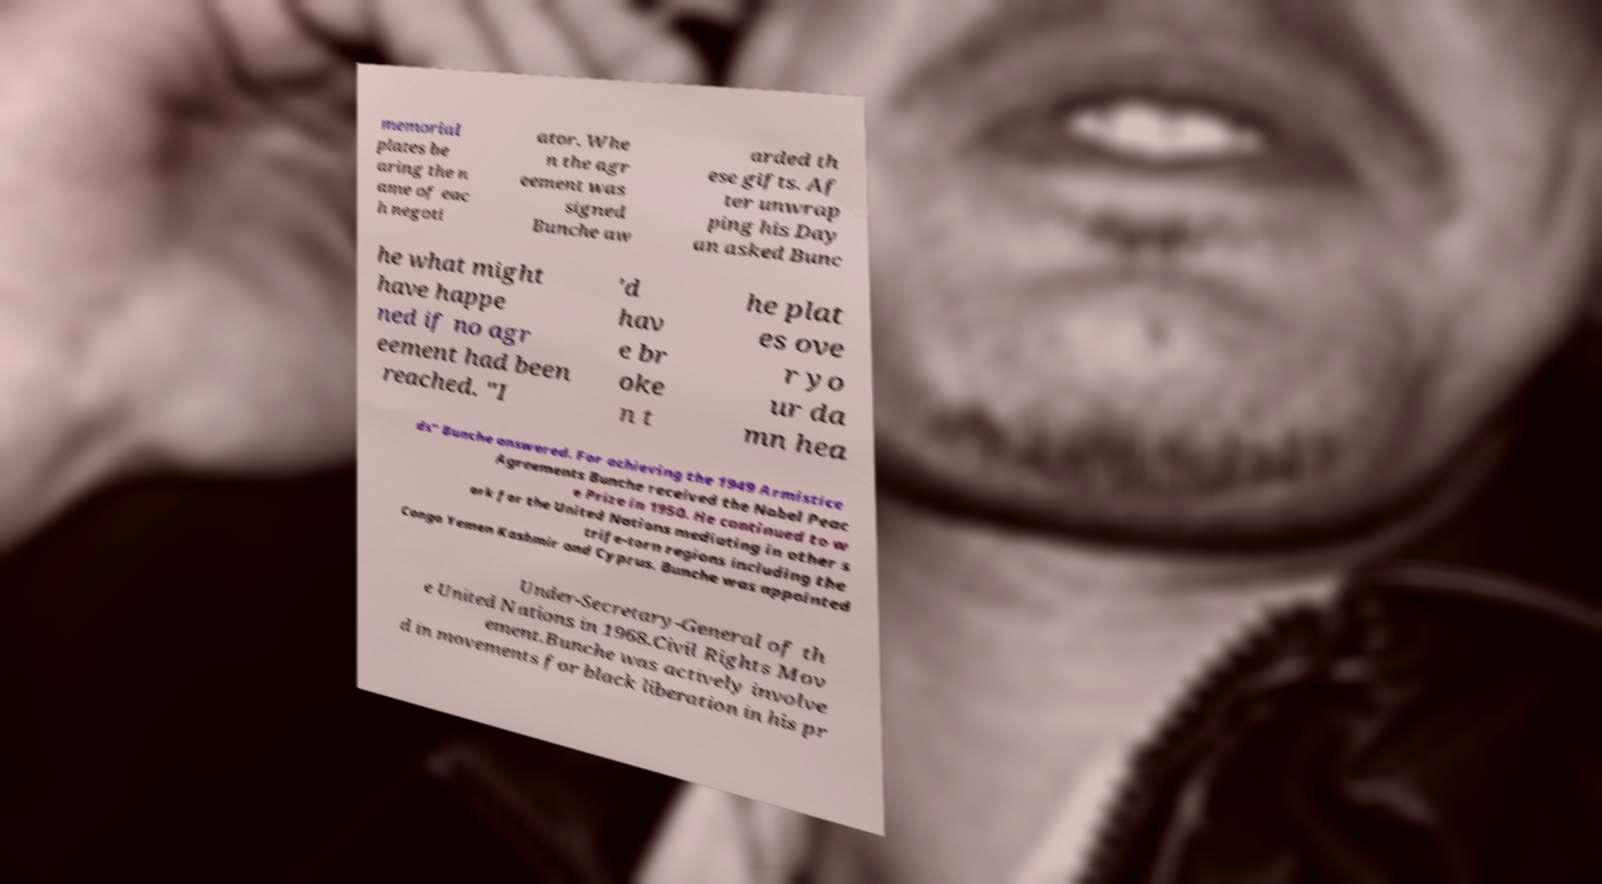There's text embedded in this image that I need extracted. Can you transcribe it verbatim? memorial plates be aring the n ame of eac h negoti ator. Whe n the agr eement was signed Bunche aw arded th ese gifts. Af ter unwrap ping his Day an asked Bunc he what might have happe ned if no agr eement had been reached. "I 'd hav e br oke n t he plat es ove r yo ur da mn hea ds" Bunche answered. For achieving the 1949 Armistice Agreements Bunche received the Nobel Peac e Prize in 1950. He continued to w ork for the United Nations mediating in other s trife-torn regions including the Congo Yemen Kashmir and Cyprus. Bunche was appointed Under-Secretary-General of th e United Nations in 1968.Civil Rights Mov ement.Bunche was actively involve d in movements for black liberation in his pr 